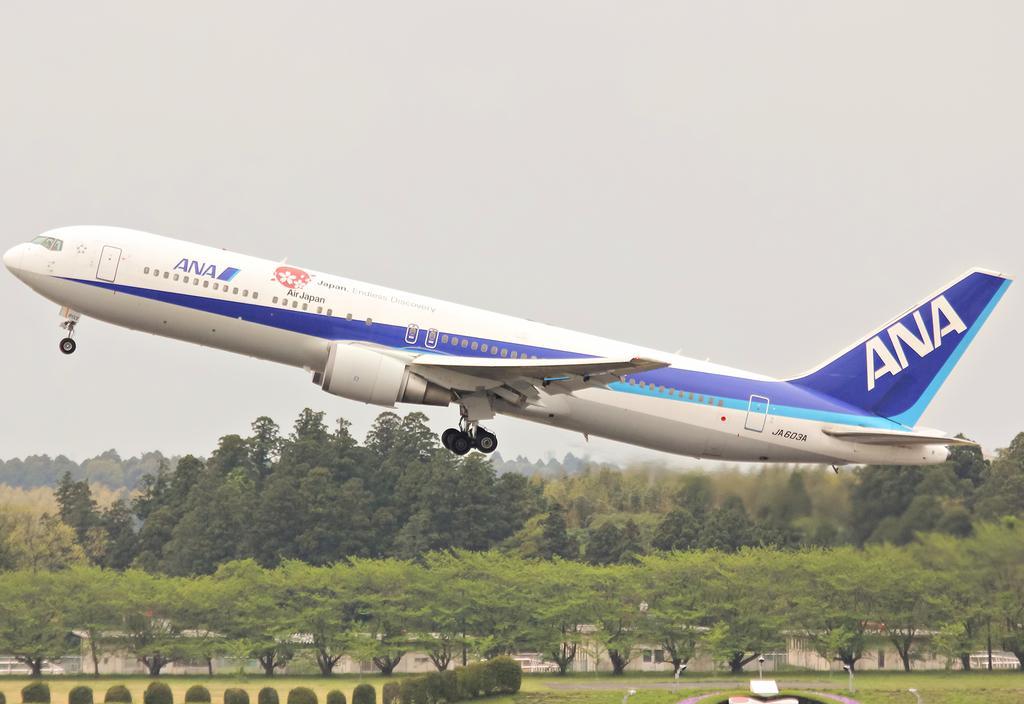Could you give a brief overview of what you see in this image? In this picture we can see an airplane flying, here we can see trees, sheds and some objects and we can see sky in the background. 